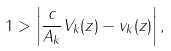<formula> <loc_0><loc_0><loc_500><loc_500>1 > \left | \frac { c } { A _ { k } } V _ { k } ( z ) - v _ { k } ( z ) \right | ,</formula> 